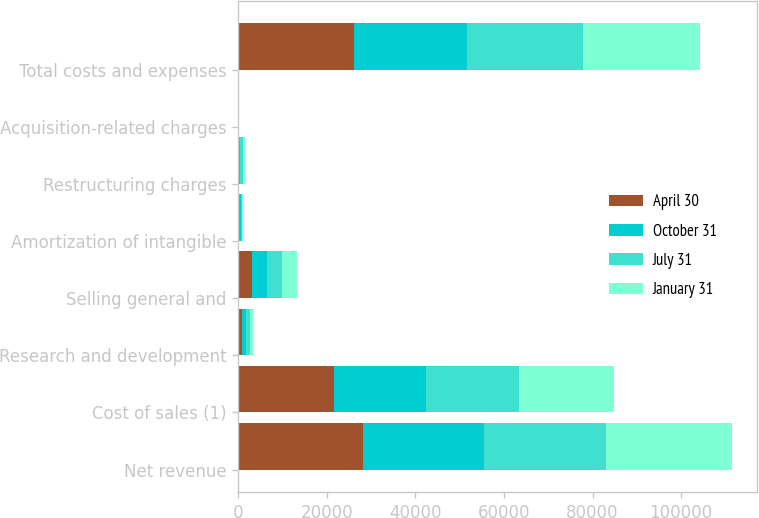Convert chart. <chart><loc_0><loc_0><loc_500><loc_500><stacked_bar_chart><ecel><fcel>Net revenue<fcel>Cost of sales (1)<fcel>Research and development<fcel>Selling general and<fcel>Amortization of intangible<fcel>Restructuring charges<fcel>Acquisition-related charges<fcel>Total costs and expenses<nl><fcel>April 30<fcel>28154<fcel>21736<fcel>811<fcel>3210<fcel>283<fcel>114<fcel>3<fcel>26157<nl><fcel>October 31<fcel>27309<fcel>20704<fcel>873<fcel>3391<fcel>264<fcel>252<fcel>3<fcel>25487<nl><fcel>July 31<fcel>27585<fcel>20974<fcel>887<fcel>3388<fcel>227<fcel>649<fcel>2<fcel>26127<nl><fcel>January 31<fcel>28406<fcel>21425<fcel>876<fcel>3364<fcel>226<fcel>604<fcel>3<fcel>26498<nl></chart> 